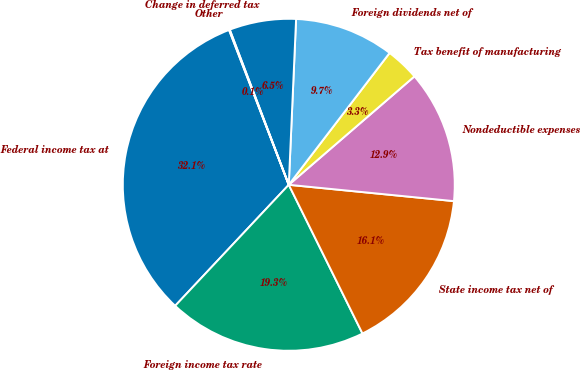<chart> <loc_0><loc_0><loc_500><loc_500><pie_chart><fcel>Federal income tax at<fcel>Foreign income tax rate<fcel>State income tax net of<fcel>Nondeductible expenses<fcel>Tax benefit of manufacturing<fcel>Foreign dividends net of<fcel>Change in deferred tax<fcel>Other<nl><fcel>32.15%<fcel>19.32%<fcel>16.11%<fcel>12.9%<fcel>3.28%<fcel>9.69%<fcel>6.49%<fcel>0.07%<nl></chart> 